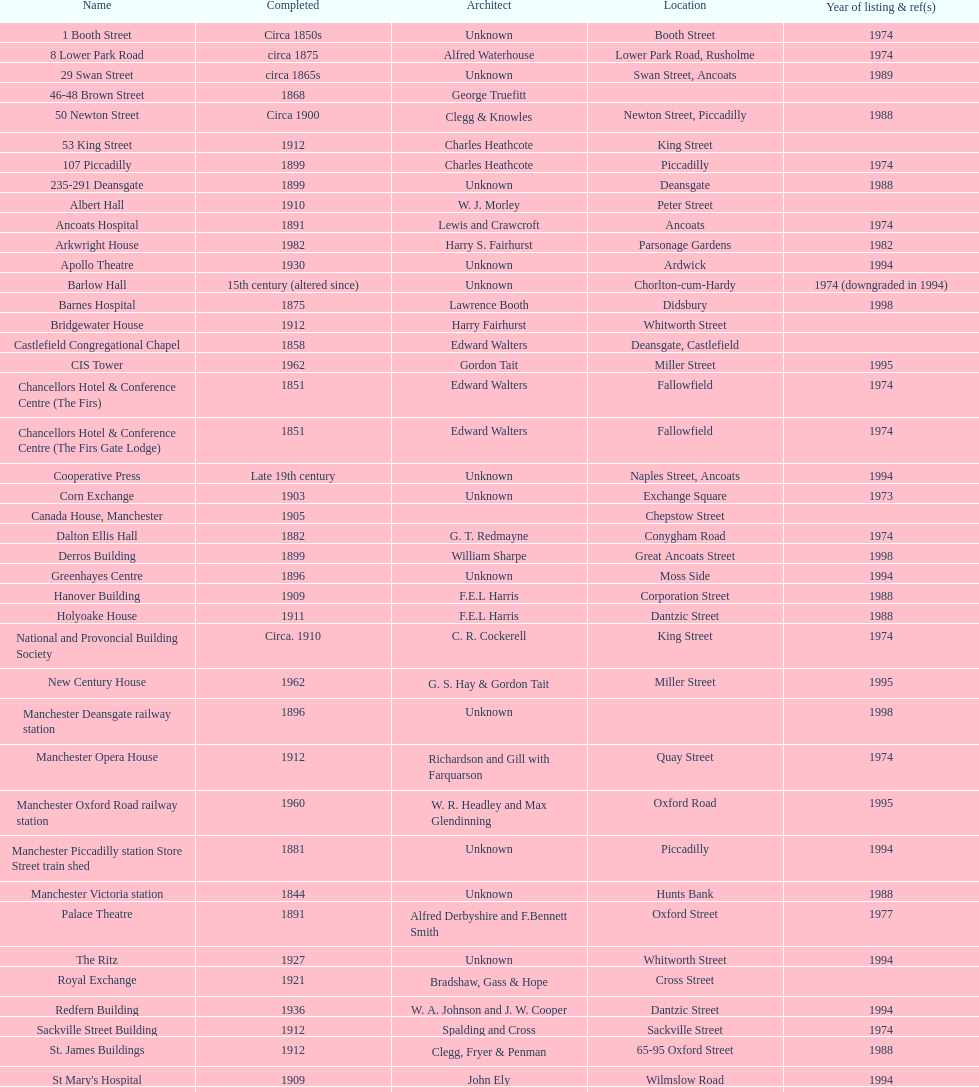How many buildings has the same year of listing as 1974? 15. 